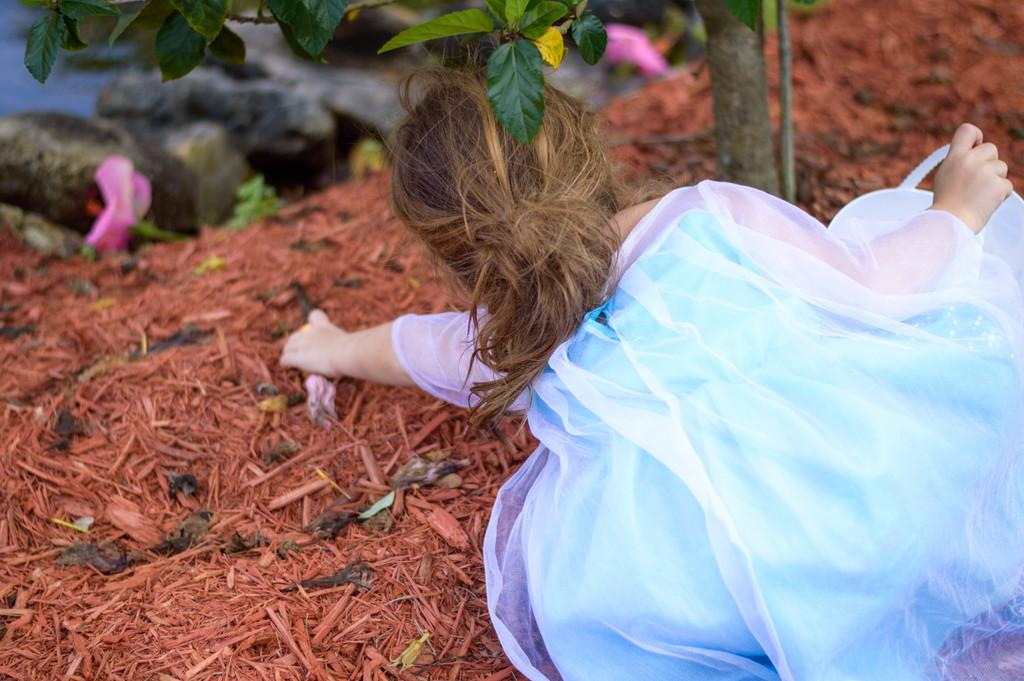Who is present in the image? There is a girl in the image. What is the girl holding in the image? The girl is holding something. What can be seen in the background of the image? There is a tree in the background of the image. What color are the objects on the ground in the image? There are brown color things on the ground in the image. How does the girl balance the pump on her head in the image? There is no pump present in the image, and the girl is not balancing anything on her head. 